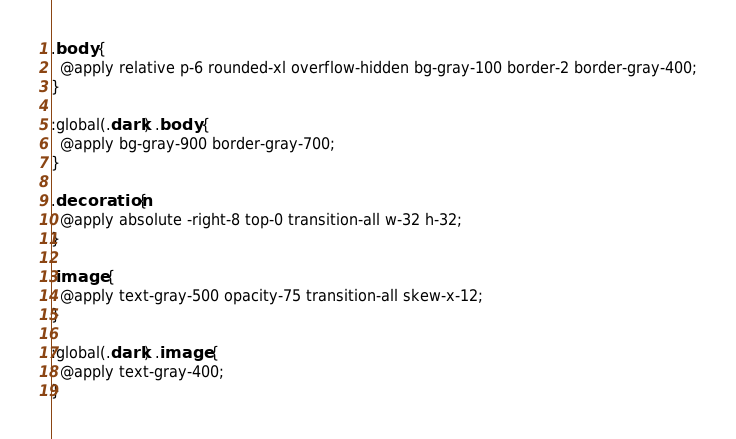Convert code to text. <code><loc_0><loc_0><loc_500><loc_500><_CSS_>.body {
  @apply relative p-6 rounded-xl overflow-hidden bg-gray-100 border-2 border-gray-400;
}

:global(.dark) .body {
  @apply bg-gray-900 border-gray-700;
}

.decoration {
  @apply absolute -right-8 top-0 transition-all w-32 h-32;
}

.image {
  @apply text-gray-500 opacity-75 transition-all skew-x-12;
}

:global(.dark) .image {
  @apply text-gray-400;
}
</code> 